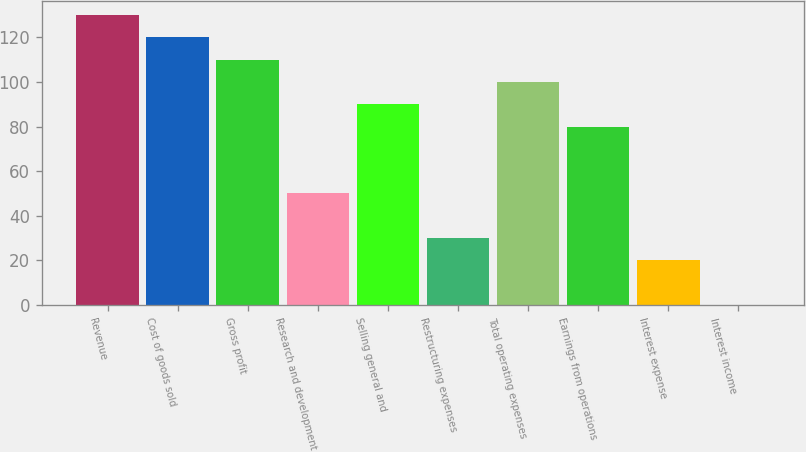<chart> <loc_0><loc_0><loc_500><loc_500><bar_chart><fcel>Revenue<fcel>Cost of goods sold<fcel>Gross profit<fcel>Research and development<fcel>Selling general and<fcel>Restructuring expenses<fcel>Total operating expenses<fcel>Earnings from operations<fcel>Interest expense<fcel>Interest income<nl><fcel>129.97<fcel>119.98<fcel>109.99<fcel>50.05<fcel>90.01<fcel>30.07<fcel>100<fcel>80.02<fcel>20.08<fcel>0.1<nl></chart> 